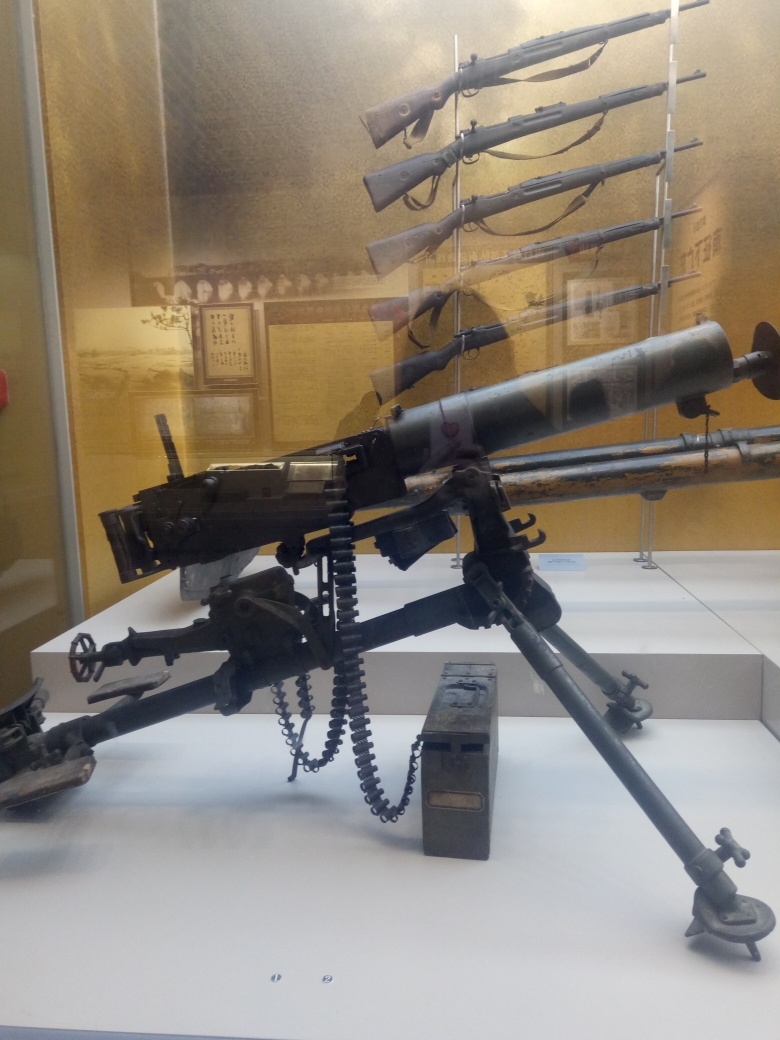Can you provide historical context or information about the types of firearms on display here? Certainly! The machine gun with the belt of ammunition appears to be a heavy or medium model, suggesting a design used for sustained firepower, potentially in a defensive position or mounted on a vehicle. The rifles in the background could be from various eras and might be bolt-action types, which would indicate usage from the late 19th to the mid-20th century. They are displayed in ascending order, which might suggest a chronological exhibit of the evolution of firearms.  How were these firearms typically used in their respective time periods? The machine gun would likely have been a key asset in both World Wars, used to control large areas and defend key positions. It would require a team to operate and could be devastating against infantry attacks. The rifles would have evolved from single-shot weapons to repeaters and bolt-action systems, increasing in firepower and rate of fire as technology progressed. They were used by infantry and were pivotal in shifting the tactics from line warfare to more dynamic, cover-based strategies. 